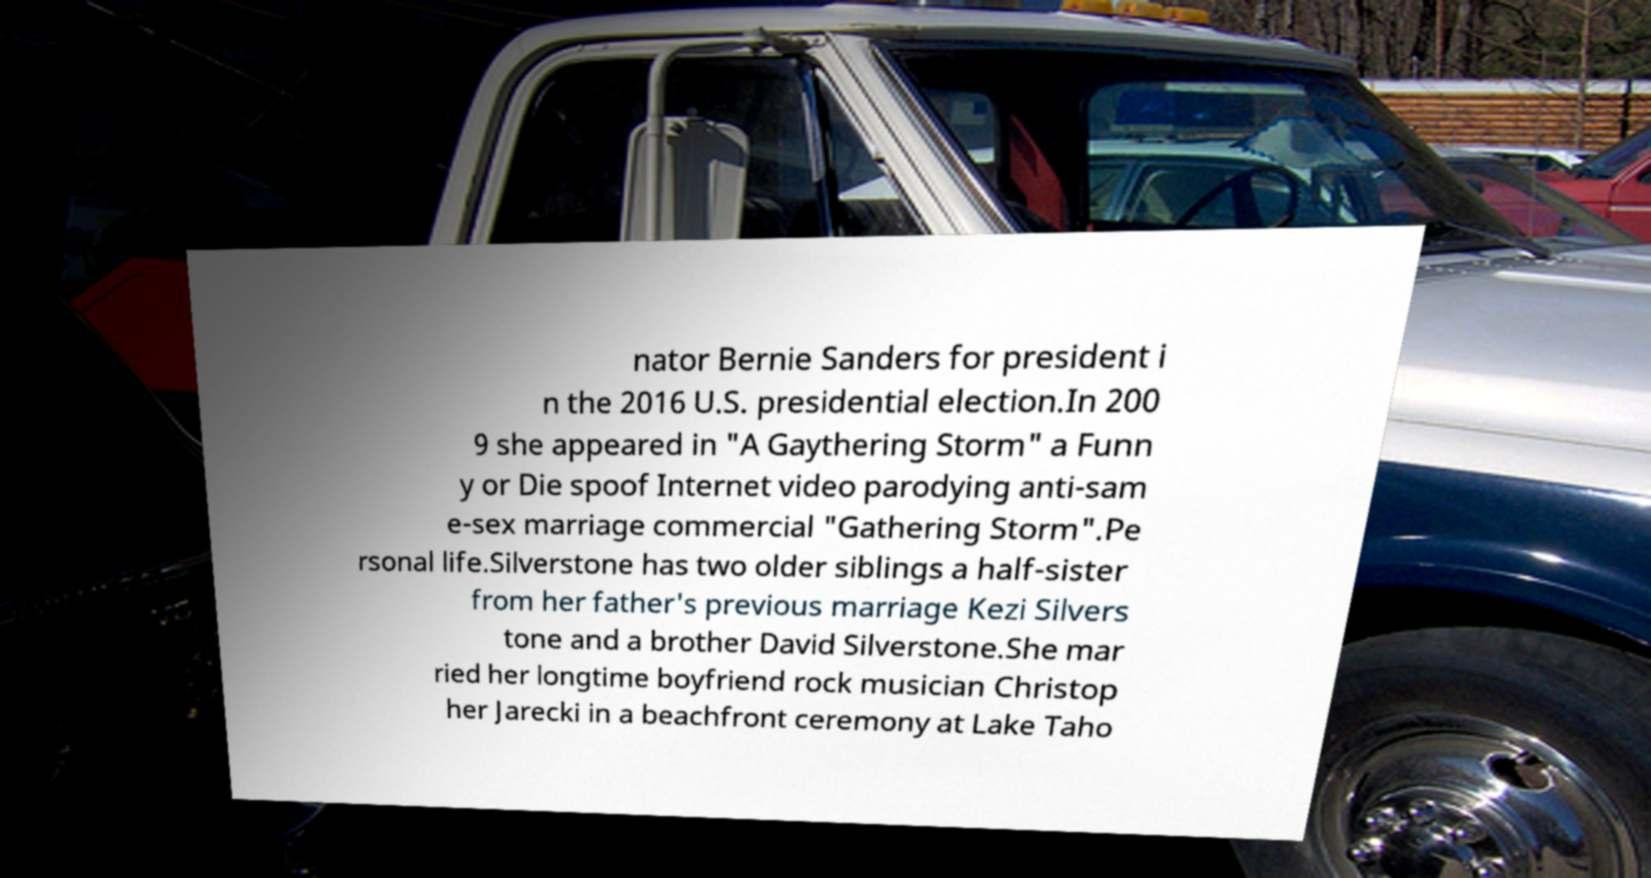There's text embedded in this image that I need extracted. Can you transcribe it verbatim? nator Bernie Sanders for president i n the 2016 U.S. presidential election.In 200 9 she appeared in "A Gaythering Storm" a Funn y or Die spoof Internet video parodying anti-sam e-sex marriage commercial "Gathering Storm".Pe rsonal life.Silverstone has two older siblings a half-sister from her father's previous marriage Kezi Silvers tone and a brother David Silverstone.She mar ried her longtime boyfriend rock musician Christop her Jarecki in a beachfront ceremony at Lake Taho 